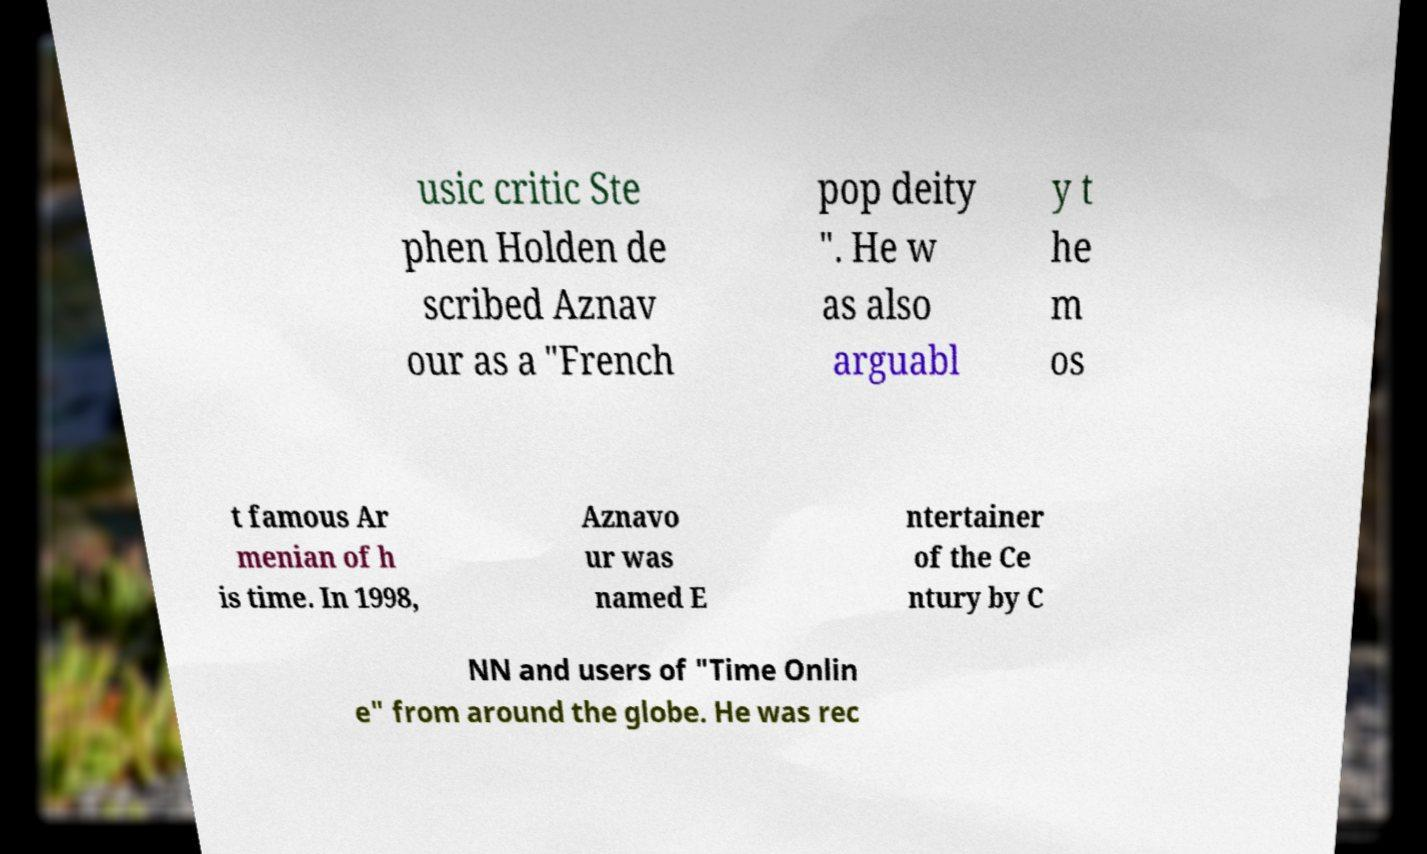I need the written content from this picture converted into text. Can you do that? usic critic Ste phen Holden de scribed Aznav our as a "French pop deity ". He w as also arguabl y t he m os t famous Ar menian of h is time. In 1998, Aznavo ur was named E ntertainer of the Ce ntury by C NN and users of "Time Onlin e" from around the globe. He was rec 